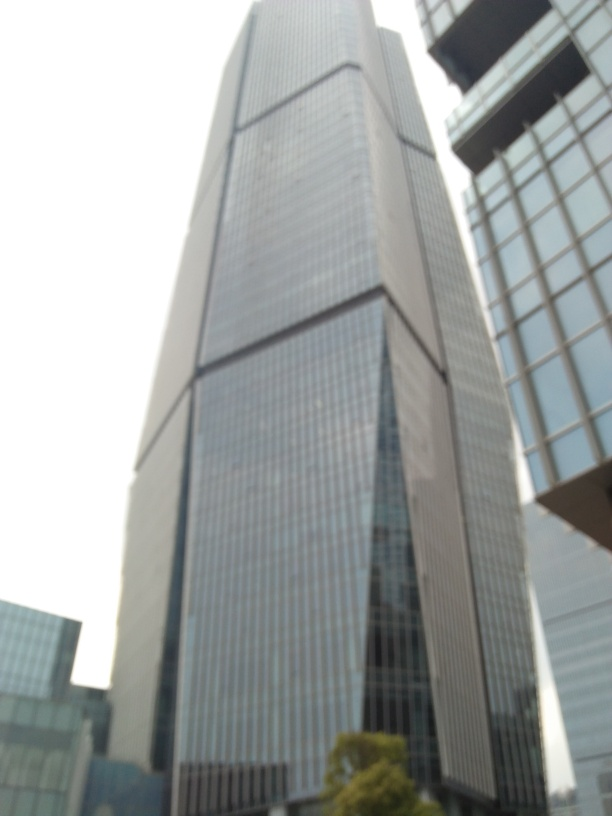What style of architecture does this building represent? The building in the image exhibits characteristics of modern architecture, emphasizing simplicity with its geometric form and use of glass as a primary exterior material. Could you tell me more about this architectural style? Certainly! Modern architecture, which became popular in the 20th century, often focuses on clean lines, minimal ornamentation, and functional design. It frequently incorporates industrial materials such as steel and glass, reflecting the technological advances of the era. 